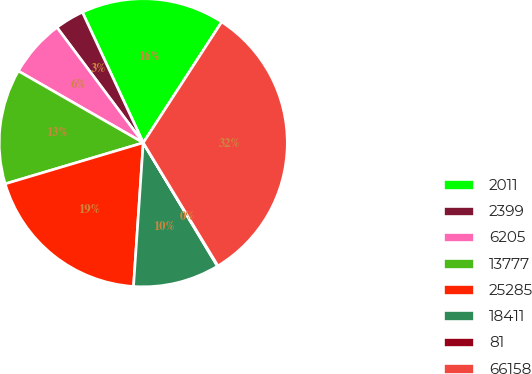Convert chart to OTSL. <chart><loc_0><loc_0><loc_500><loc_500><pie_chart><fcel>2011<fcel>2399<fcel>6205<fcel>13777<fcel>25285<fcel>18411<fcel>81<fcel>66158<nl><fcel>16.11%<fcel>3.28%<fcel>6.48%<fcel>12.9%<fcel>19.32%<fcel>9.69%<fcel>0.07%<fcel>32.15%<nl></chart> 